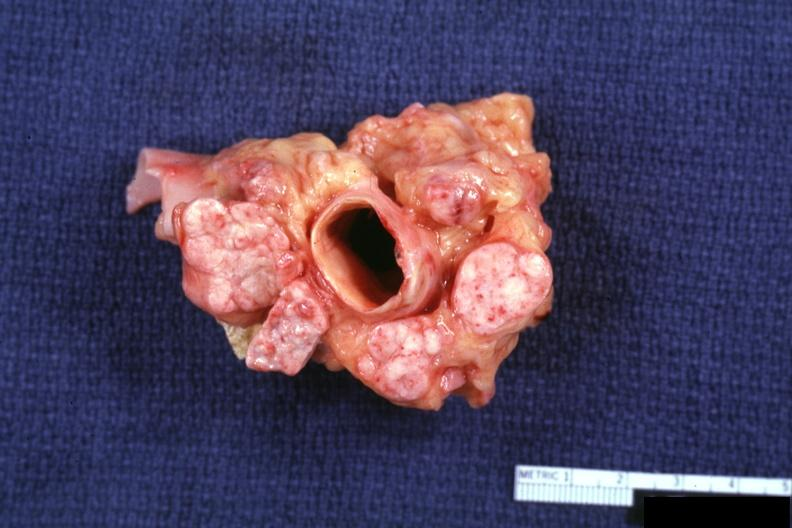what does this image show?
Answer the question using a single word or phrase. Excellent cross section of aorta and nodes with obvious tumor in enlarged nodes 